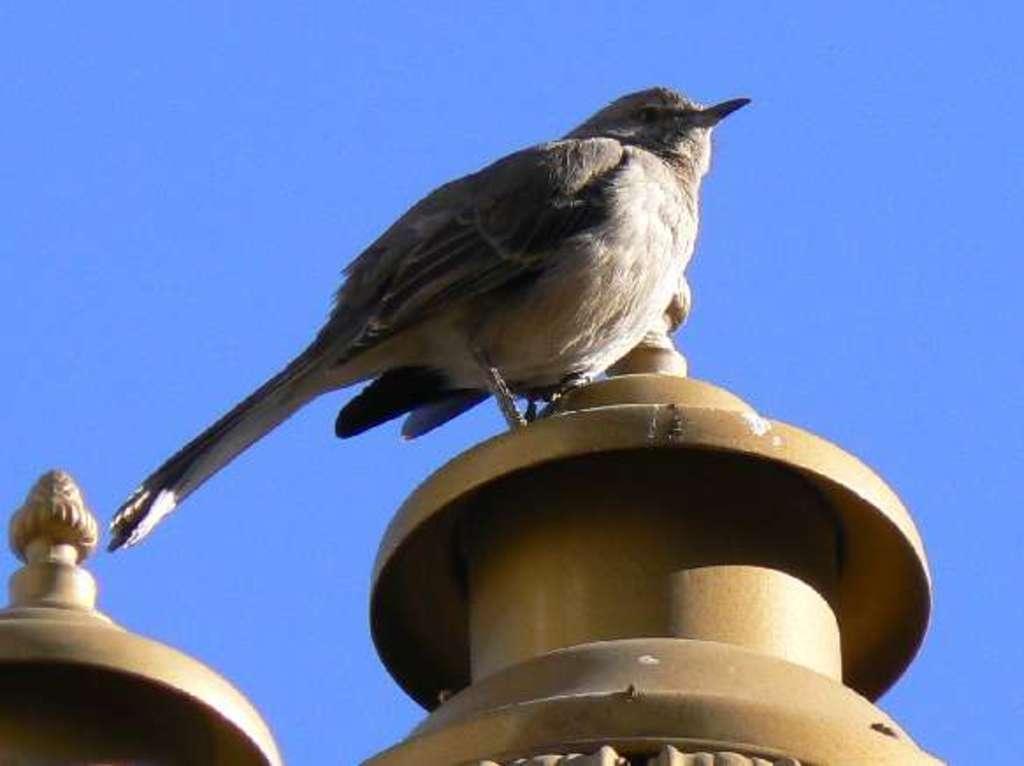Could you give a brief overview of what you see in this image? At the bottom of the image there are some poles, on the poles there is a bird. Behind the bird there is sky. 